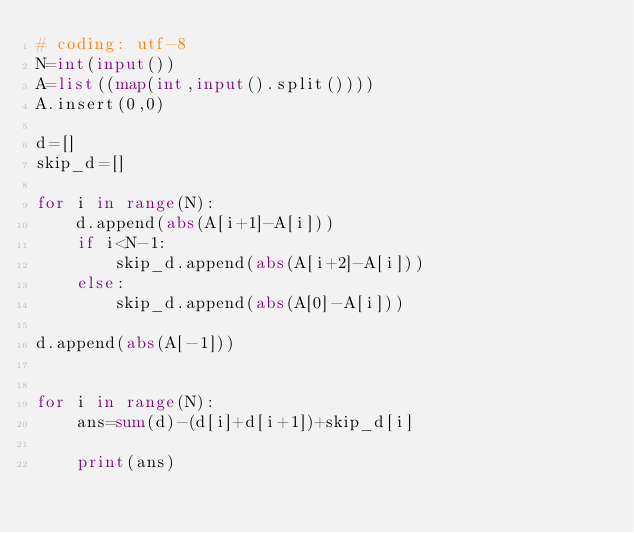<code> <loc_0><loc_0><loc_500><loc_500><_Python_># coding: utf-8
N=int(input())
A=list((map(int,input().split())))
A.insert(0,0)

d=[]
skip_d=[]

for i in range(N):
    d.append(abs(A[i+1]-A[i]))
    if i<N-1:
        skip_d.append(abs(A[i+2]-A[i]))
    else:
        skip_d.append(abs(A[0]-A[i]))

d.append(abs(A[-1]))


for i in range(N):
    ans=sum(d)-(d[i]+d[i+1])+skip_d[i]
    
    print(ans)</code> 